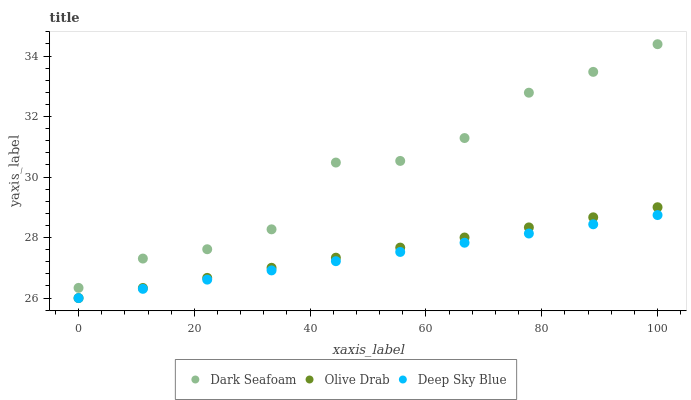Does Deep Sky Blue have the minimum area under the curve?
Answer yes or no. Yes. Does Dark Seafoam have the maximum area under the curve?
Answer yes or no. Yes. Does Olive Drab have the minimum area under the curve?
Answer yes or no. No. Does Olive Drab have the maximum area under the curve?
Answer yes or no. No. Is Olive Drab the smoothest?
Answer yes or no. Yes. Is Dark Seafoam the roughest?
Answer yes or no. Yes. Is Deep Sky Blue the smoothest?
Answer yes or no. No. Is Deep Sky Blue the roughest?
Answer yes or no. No. Does Deep Sky Blue have the lowest value?
Answer yes or no. Yes. Does Dark Seafoam have the highest value?
Answer yes or no. Yes. Does Olive Drab have the highest value?
Answer yes or no. No. Is Olive Drab less than Dark Seafoam?
Answer yes or no. Yes. Is Dark Seafoam greater than Deep Sky Blue?
Answer yes or no. Yes. Does Olive Drab intersect Deep Sky Blue?
Answer yes or no. Yes. Is Olive Drab less than Deep Sky Blue?
Answer yes or no. No. Is Olive Drab greater than Deep Sky Blue?
Answer yes or no. No. Does Olive Drab intersect Dark Seafoam?
Answer yes or no. No. 